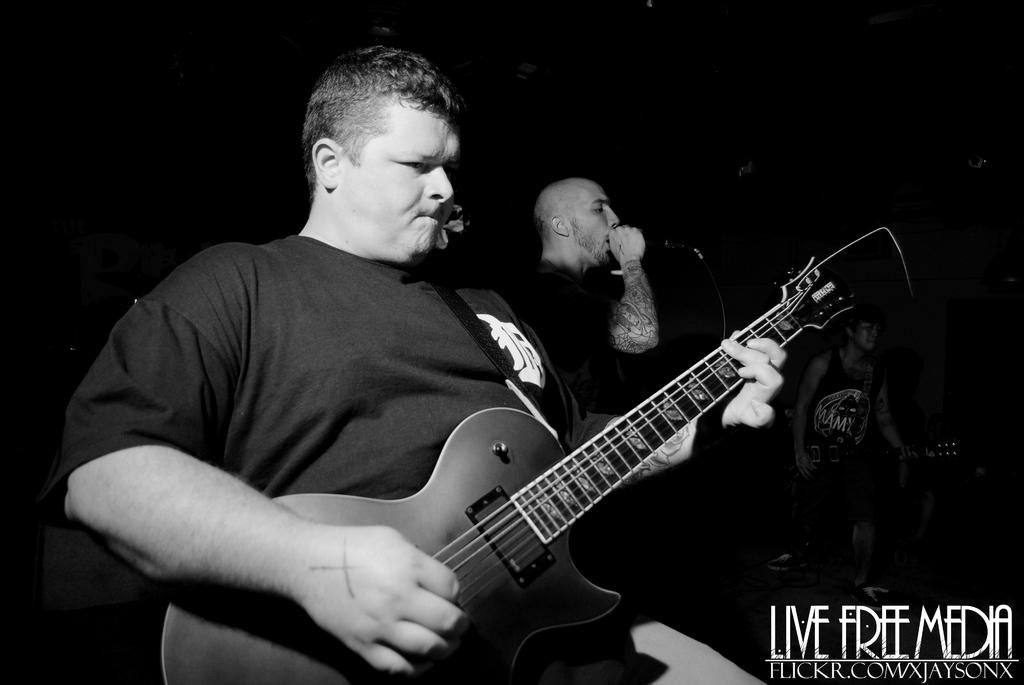What are the persons in the image holding? The persons in the image are holding guitars. What is the man in the middle holding? The man in the middle is holding a microphone. What color scheme is used in the image? The image is in black and white color. What type of crime is being committed in the image? There is no crime being committed in the image; it features persons holding guitars and a man holding a microphone. What color is the underwear worn by the persons in the image? There is no underwear visible in the image, as it is in black and white color and focused on the persons holding guitars and the man holding a microphone. 